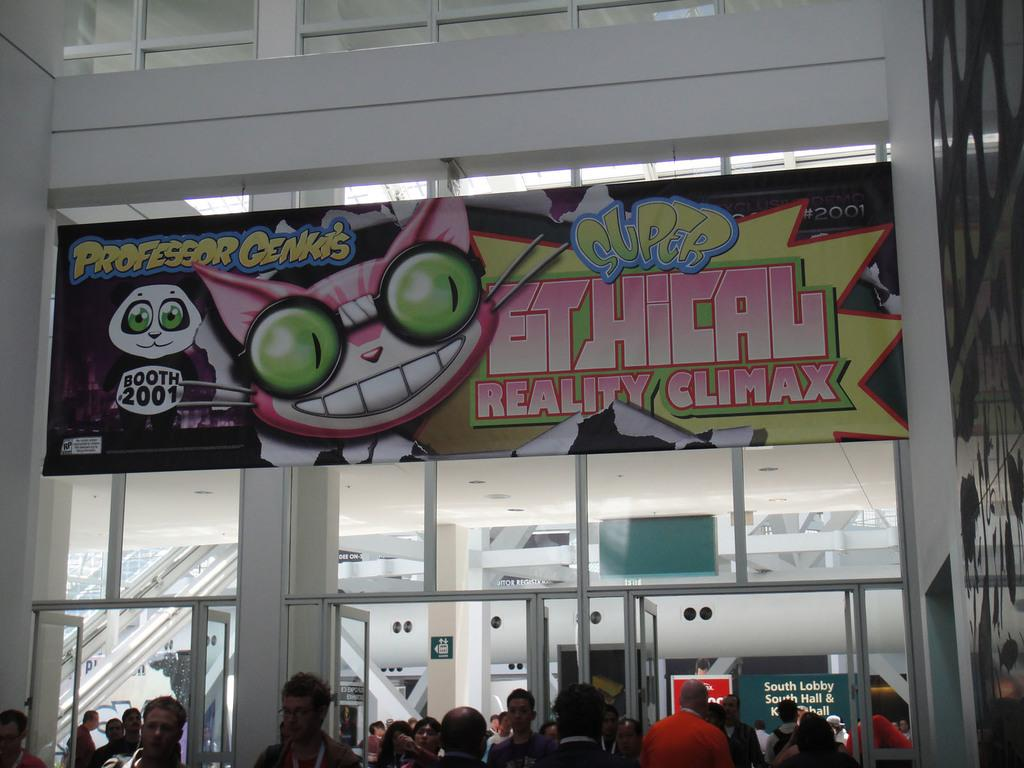What type of structure is visible in the image? There is a building in the image. Who or what can be seen near the building? There is a group of people in the image. What are the name boards used for in the image? Name boards are present in the image to provide information or directions. What architectural features are visible on the building? Pillars are visible in the image. How can the building be accessed? Doors are present in the image. What provides illumination in the image? Lights are visible in the image. What other objects are present in the image? There are some objects in the image. Are the people in the image discussing their swimming techniques? There is no indication in the image that the people are discussing swimming techniques. 